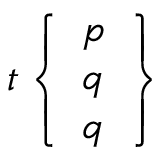Convert formula to latex. <formula><loc_0><loc_0><loc_500><loc_500>t \left \{ { \begin{array} { l } { p } \\ { q } \\ { q } \end{array} } \right \}</formula> 